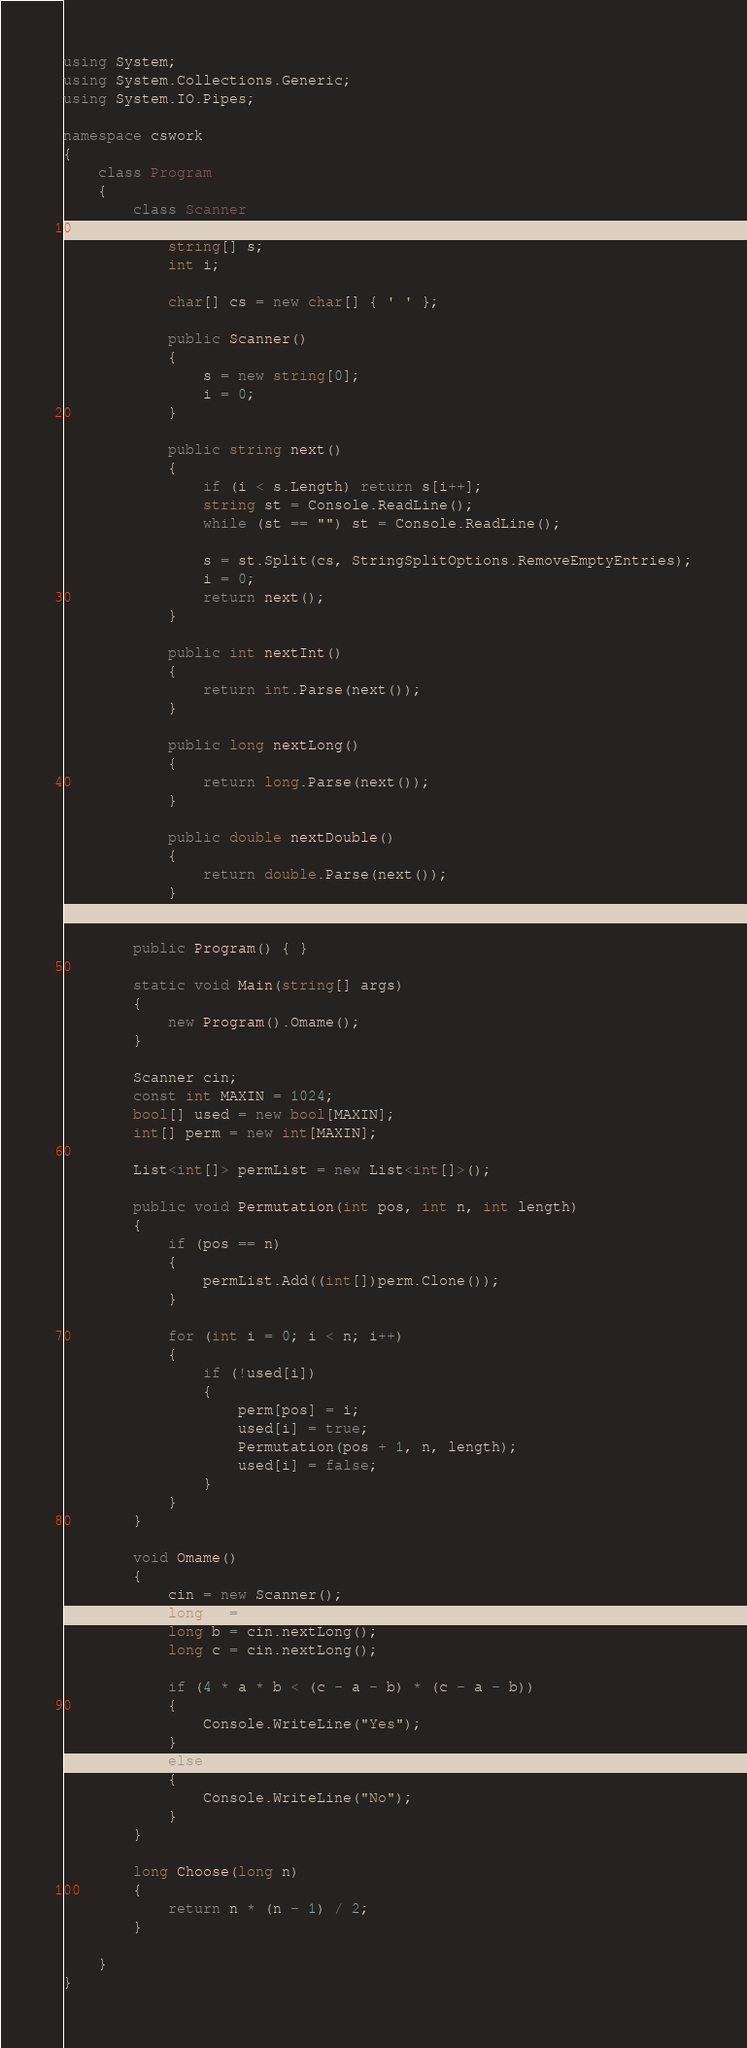Convert code to text. <code><loc_0><loc_0><loc_500><loc_500><_C#_>using System;
using System.Collections.Generic;
using System.IO.Pipes;

namespace cswork
{
    class Program
    {
        class Scanner
        {
            string[] s;
            int i;

            char[] cs = new char[] { ' ' };

            public Scanner()
            {
                s = new string[0];
                i = 0;
            }

            public string next()
            {
                if (i < s.Length) return s[i++];
                string st = Console.ReadLine();
                while (st == "") st = Console.ReadLine();

                s = st.Split(cs, StringSplitOptions.RemoveEmptyEntries);
                i = 0;
                return next();
            }

            public int nextInt()
            {
                return int.Parse(next());
            }

            public long nextLong()
            {
                return long.Parse(next());
            }

            public double nextDouble()
            {
                return double.Parse(next());
            }
        }

        public Program() { }

        static void Main(string[] args)
        {
            new Program().Omame();
        }

        Scanner cin;
        const int MAXIN = 1024;
        bool[] used = new bool[MAXIN];
        int[] perm = new int[MAXIN];

        List<int[]> permList = new List<int[]>();

        public void Permutation(int pos, int n, int length)
        {
            if (pos == n)
            {
                permList.Add((int[])perm.Clone());
            }

            for (int i = 0; i < n; i++)
            {
                if (!used[i])
                {
                    perm[pos] = i;
                    used[i] = true;
                    Permutation(pos + 1, n, length);
                    used[i] = false;
                }
            }
        }

        void Omame()
        {
            cin = new Scanner();
            long a = cin.nextLong();
            long b = cin.nextLong();
            long c = cin.nextLong();

            if (4 * a * b < (c - a - b) * (c - a - b))
            {
                Console.WriteLine("Yes");
            }
            else
            {
                Console.WriteLine("No");
            }
        }

        long Choose(long n)
        {
            return n * (n - 1) / 2;
        }

    }
}
</code> 